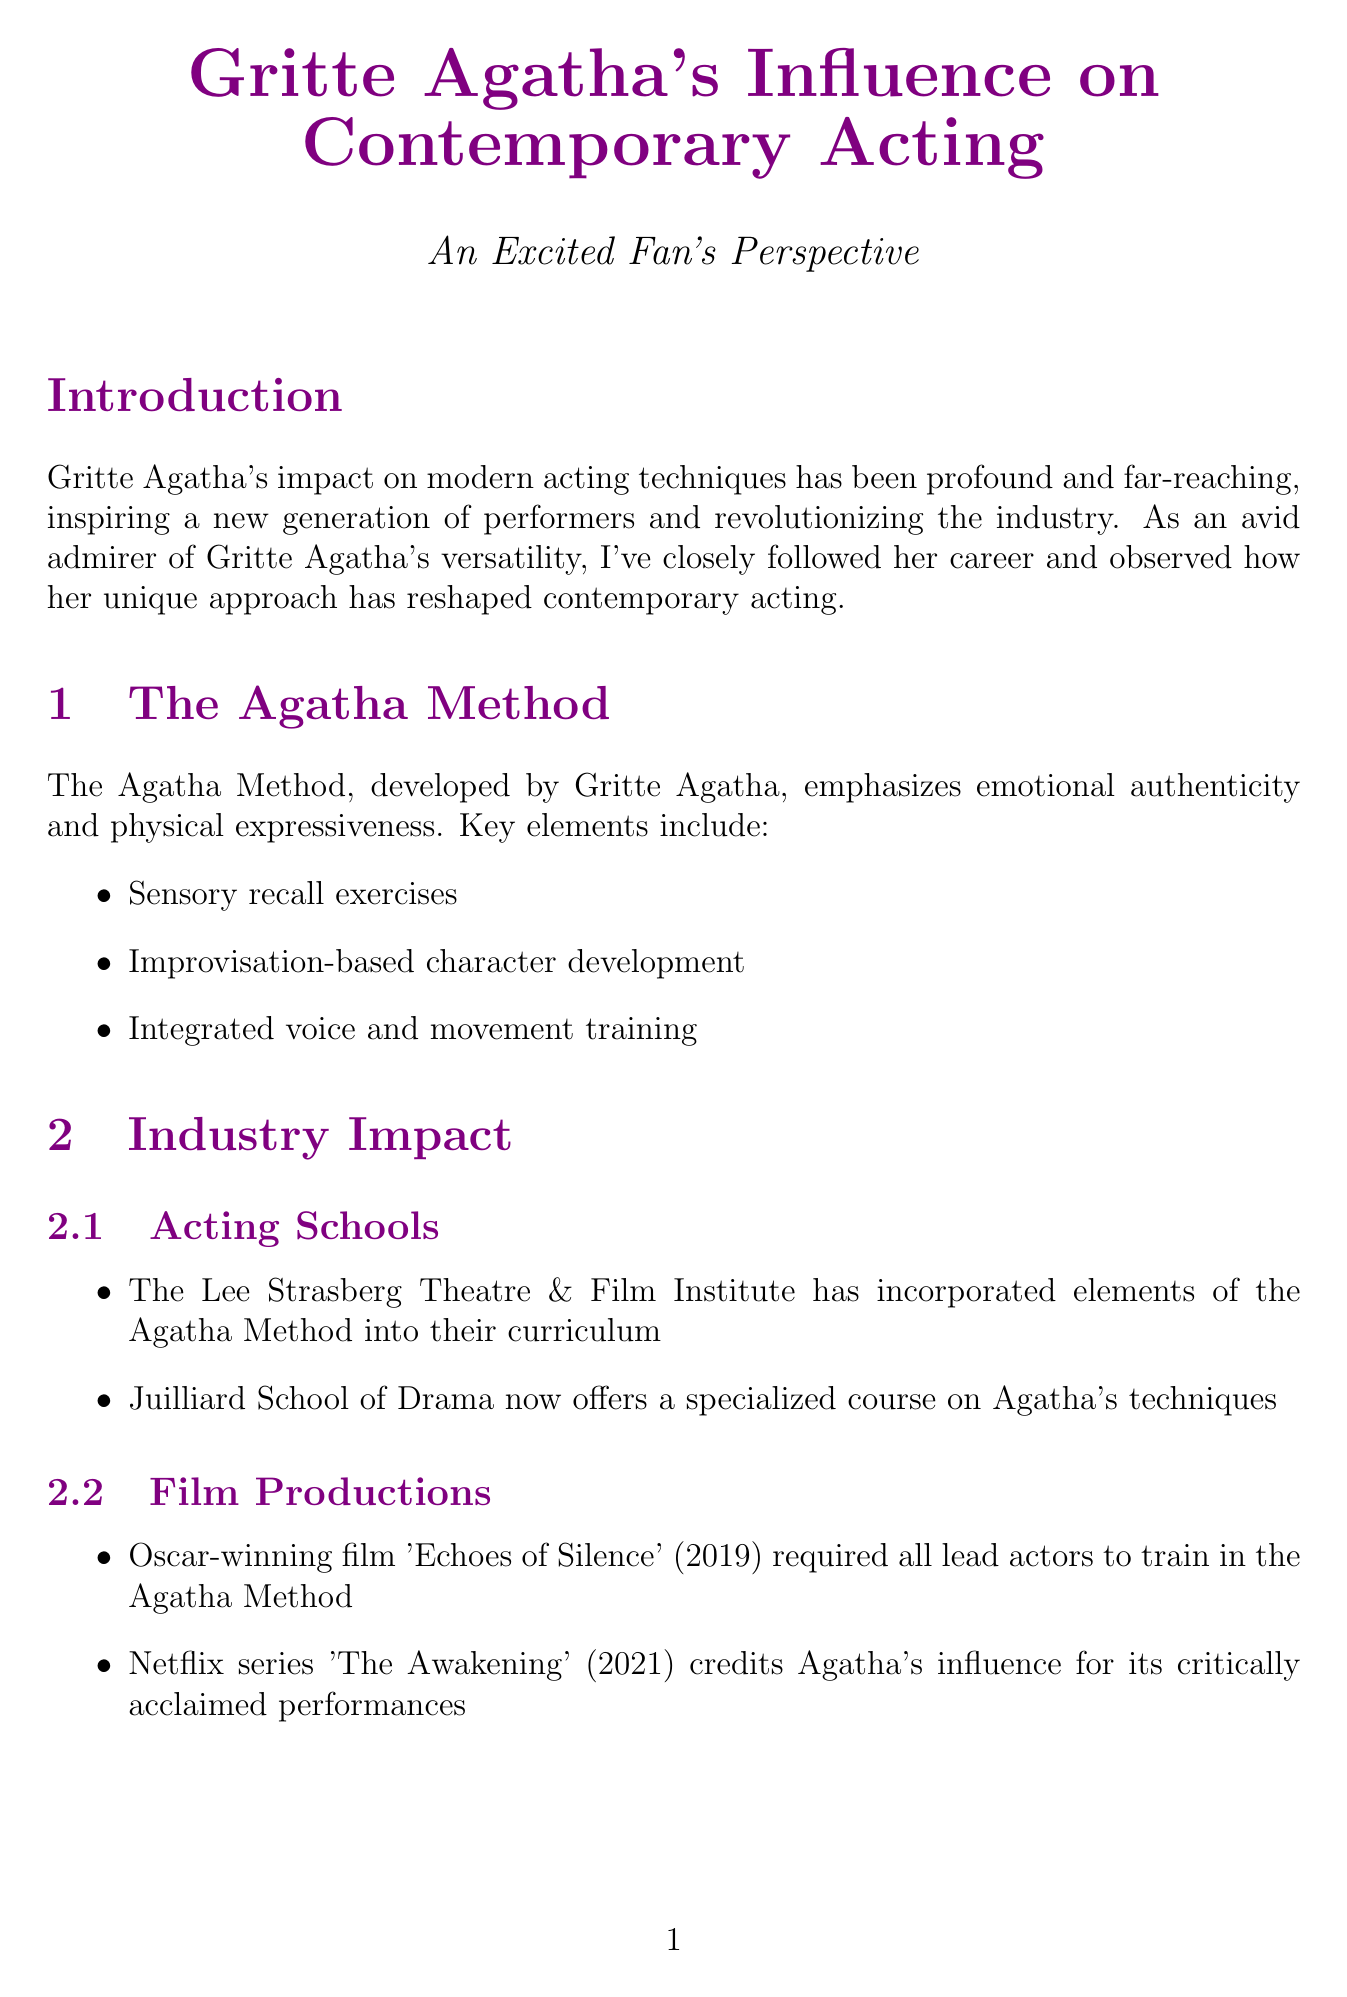What is the main focus of Gritte Agatha's techniques? The main focus of Gritte Agatha's techniques is emotional authenticity and physical expressiveness.
Answer: emotional authenticity and physical expressiveness Which prestigious acting school incorporates the Agatha Method? The Lee Strasberg Theatre & Film Institute incorporates elements of the Agatha Method into their curriculum.
Answer: The Lee Strasberg Theatre & Film Institute What year was the Oscar-winning film 'Echoes of Silence' released? The Oscar-winning film 'Echoes of Silence' was released in 2019.
Answer: 2019 Who described the Agatha Method as transformative for their career? Viola Davis described the Agatha Method as transformative for her career.
Answer: Viola Davis What are actors trained in the Agatha Method said to bring to their performances? Actors trained in the Agatha Method bring an unparalleled depth to their performances.
Answer: unparalleled depth What emerging trend involves virtual reality? The integration of Agatha's techniques with virtual reality acting is an emerging trend.
Answer: virtual reality acting What challenge is associated with training in the Agatha Method? A challenge associated with training in the Agatha Method is that it requires significant time investment.
Answer: significant time investment What specialized course does Juilliard School of Drama offer? Juilliard School of Drama offers a specialized course on Agatha's techniques.
Answer: specialized course on Agatha's techniques 